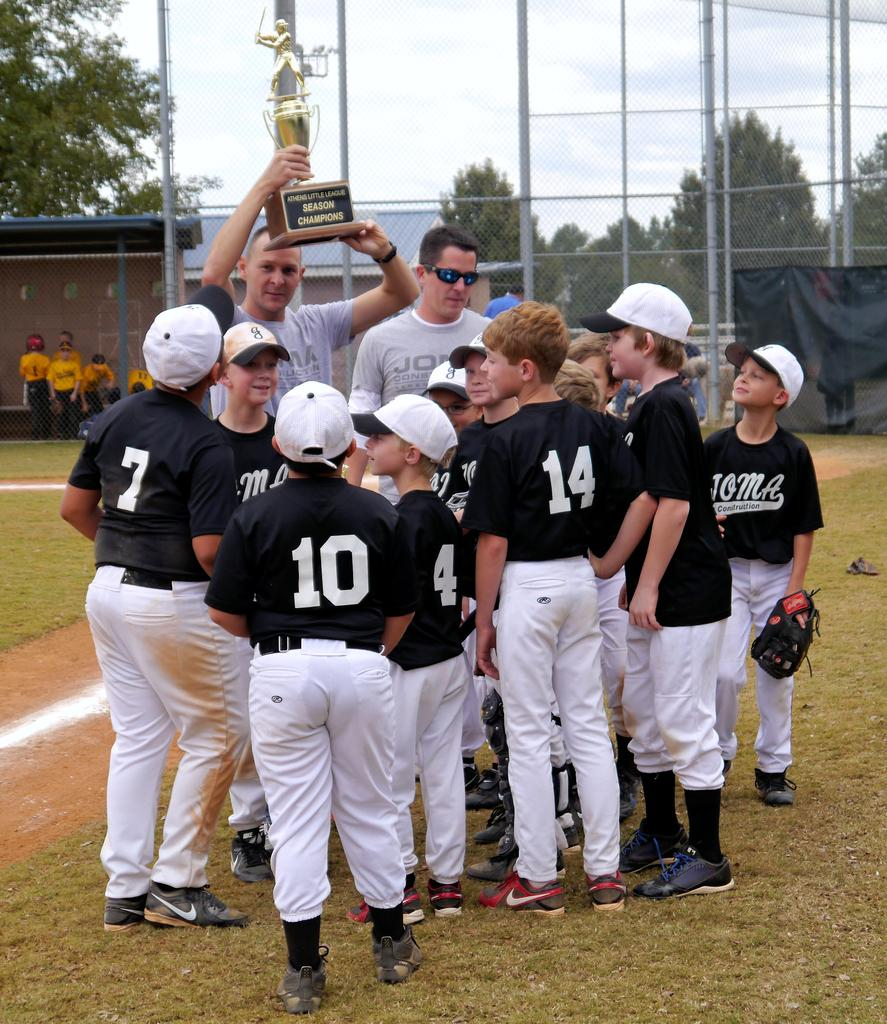<image>
Describe the image concisely. A Little League team admires the trophy they won for being the Season Champions. 